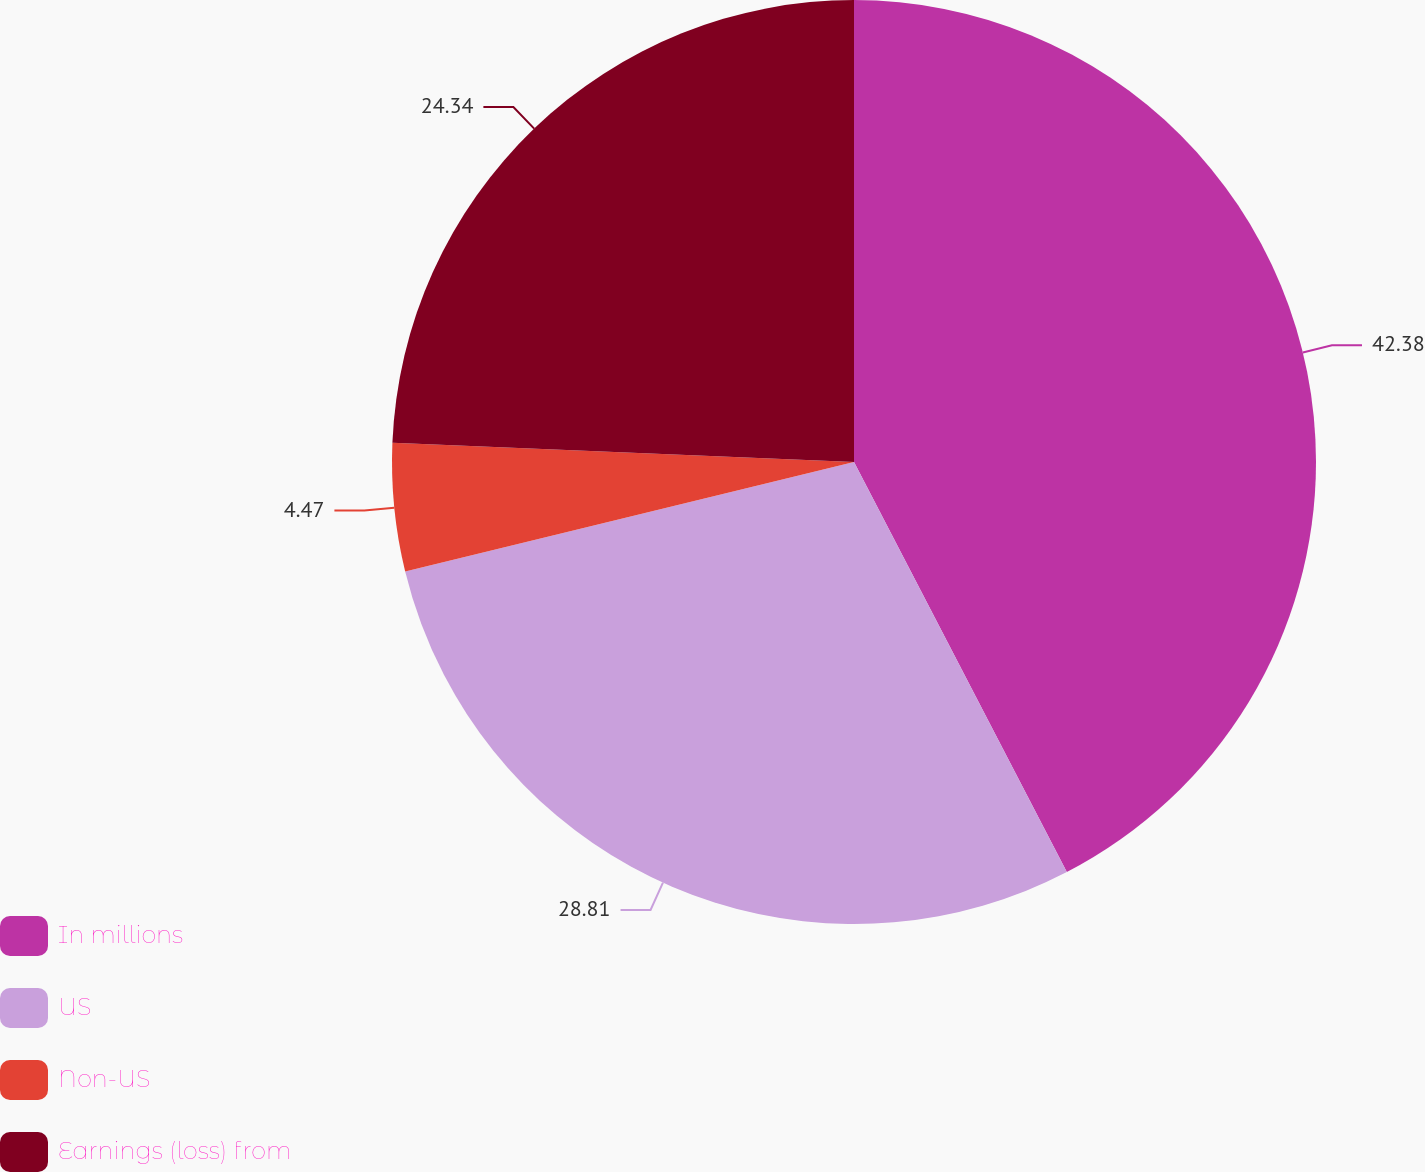Convert chart to OTSL. <chart><loc_0><loc_0><loc_500><loc_500><pie_chart><fcel>In millions<fcel>US<fcel>Non-US<fcel>Earnings (loss) from<nl><fcel>42.38%<fcel>28.81%<fcel>4.47%<fcel>24.34%<nl></chart> 